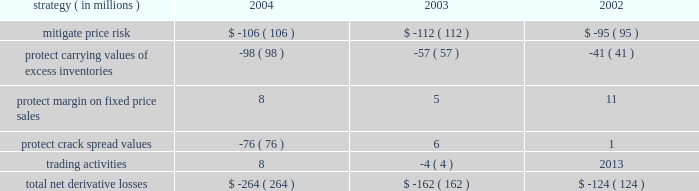Rm&t segment we do not attempt to qualify commodity derivative instruments used in our rm&t operations for hedge accounting .
As a result , we recognize all changes in the fair value of derivatives used in our rm&t operations in income , although most of these derivatives have an underlying physical commodity transaction .
Generally , derivative losses occur when market prices increase , which are offset by gains on the underlying physical commodity transactions .
Conversely , derivative gains occur when market prices decrease , which are offset by losses on the underlying physical commodity transactions .
Derivative gains or losses included in rm&t segment income for each of the last three years are summarized in the table : strategy ( in millions ) 2004 2003 2002 .
During 2004 , using derivative instruments map sold crack spreads forward through the fourth quarter 2005 at values higher than the company thought sustainable in the actual months these contracts expire .
Included in the $ 76 million derivative loss for 2004 noted in the above table for the 2018 2018protect crack spread values 2019 2019 strategy was approximately an $ 8 million gain due to changes in the fair value of crack-spread derivatives that will expire throughout 2005 .
In addition , natural gas options are in place to manage the price risk associated with approximately 41 percent of the first quarter 2005 anticipated natural gas purchases for refinery use .
Ig segment we have used derivative instruments to convert the fixed price of a long-term gas sales contract to market prices .
The underlying physical contract is for a specified annual quantity of gas and matures in 2008 .
Similarly , we will use derivative instruments to convert shorter term ( typically less than a year ) fixed price contracts to market prices in our ongoing purchase for resale activity ; and to hedge purchased gas injected into storage for subsequent resale .
Derivative gains included in ig segment income were $ 17 million in 2004 , compared to gains of $ 19 million in 2003 and losses of $ 8 million in 2002 .
Trading activity in the ig segment resulted in losses of $ 2 million in 2004 , compared to losses of $ 7 million in 2003 and gains of $ 4 million in 2002 and have been included in the aforementioned amounts .
Other commodity risk we are impacted by basis risk , caused by factors that affect the relationship between commodity futures prices reflected in derivative commodity instruments and the cash market price of the underlying commodity .
Natural gas transaction prices are frequently based on industry reference prices that may vary from prices experienced in local markets .
For example , new york mercantile exchange ( 2018 2018nymex 2019 2019 ) contracts for natural gas are priced at louisiana 2019s henry hub , while the underlying quantities of natural gas may be produced and sold in the western united states at prices that do not move in strict correlation with nymex prices .
If commodity price changes in one region are not reflected in other regions , derivative commodity instruments may no longer provide the expected hedge , resulting in increased exposure to basis risk .
These regional price differences could yield favorable or unfavorable results .
Otc transactions are being used to manage exposure to a portion of basis risk .
We are impacted by liquidity risk , caused by timing delays in liquidating contract positions due to a potential inability to identify a counterparty willing to accept an offsetting position .
Due to the large number of active participants , liquidity risk exposure is relatively low for exchange-traded transactions. .
Included in the derivative loss for 2004 noted in the above table for the 2018 2018protect crack spread values 2019 2019 strategy was a gain due to changes in the fair value of crack-spread derivatives that will expire throughout 2005 . what was the loss without benefit of this gain? 
Computations: (76 - 8)
Answer: 68.0. 